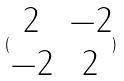<formula> <loc_0><loc_0><loc_500><loc_500>( \begin{matrix} 2 & - 2 \\ - 2 & 2 \end{matrix} )</formula> 